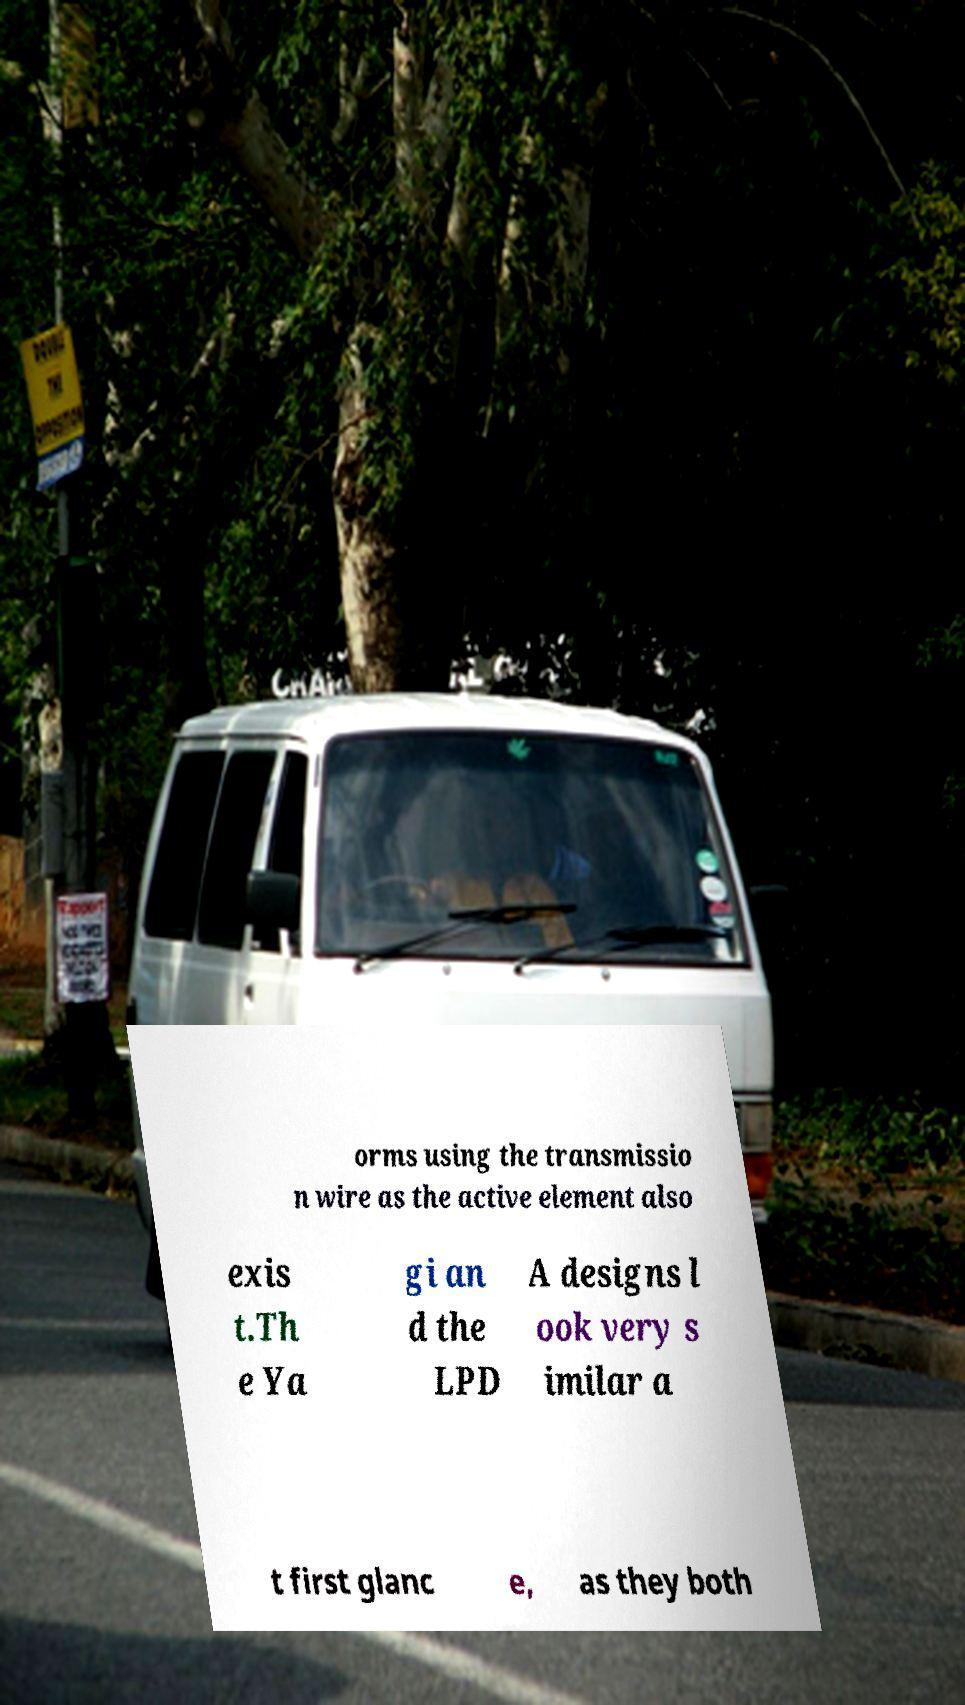For documentation purposes, I need the text within this image transcribed. Could you provide that? orms using the transmissio n wire as the active element also exis t.Th e Ya gi an d the LPD A designs l ook very s imilar a t first glanc e, as they both 